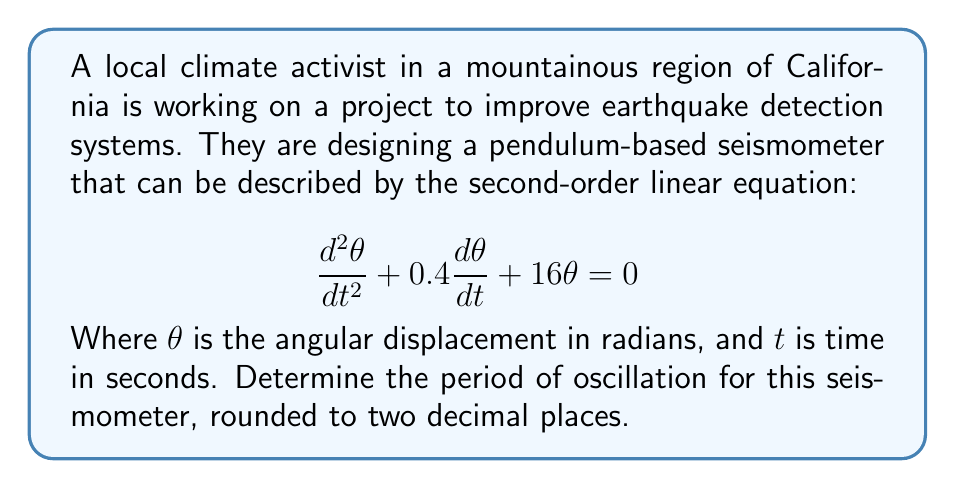What is the answer to this math problem? To find the period of oscillation, we need to follow these steps:

1) The general form of a second-order linear equation is:

   $$\frac{d^2y}{dt^2} + 2\zeta\omega_n\frac{dy}{dt} + \omega_n^2y = 0$$

   Where $\zeta$ is the damping ratio and $\omega_n$ is the natural frequency.

2) Comparing our equation to the general form, we can see that:

   $2\zeta\omega_n = 0.4$
   $\omega_n^2 = 16$

3) From $\omega_n^2 = 16$, we can determine that $\omega_n = 4$ rad/s.

4) The damped natural frequency $\omega_d$ is given by:

   $$\omega_d = \omega_n\sqrt{1-\zeta^2}$$

5) To find $\zeta$, we use the equation from step 2:

   $2\zeta(4) = 0.4$
   $\zeta = 0.05$

6) Now we can calculate $\omega_d$:

   $$\omega_d = 4\sqrt{1-0.05^2} = 4\sqrt{0.9975} = 3.99 \text{ rad/s}$$

7) The period of oscillation $T$ is related to the damped natural frequency by:

   $$T = \frac{2\pi}{\omega_d}$$

8) Substituting our value for $\omega_d$:

   $$T = \frac{2\pi}{3.99} = 1.57 \text{ seconds}$$

Rounding to two decimal places, we get 1.57 seconds.
Answer: 1.57 seconds 